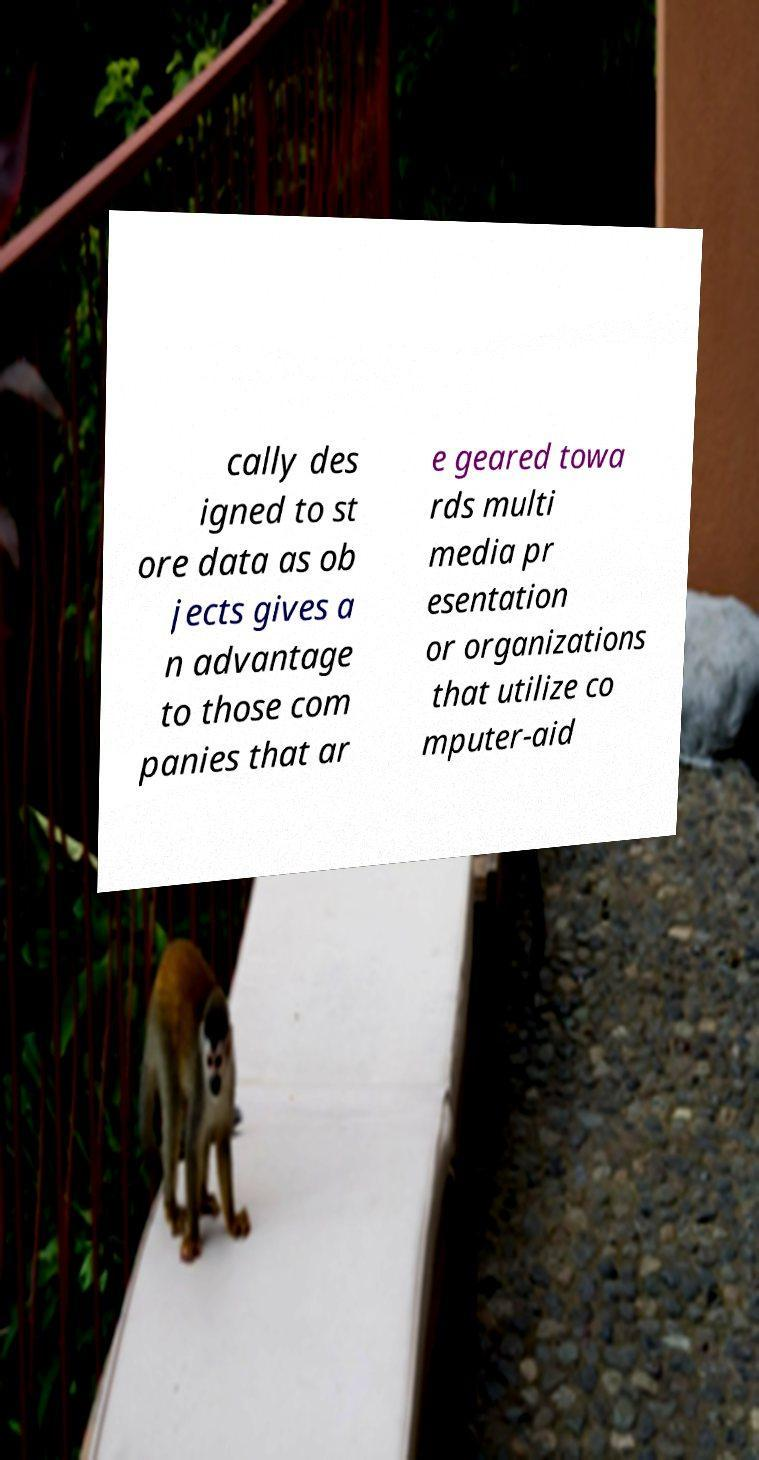Please read and relay the text visible in this image. What does it say? cally des igned to st ore data as ob jects gives a n advantage to those com panies that ar e geared towa rds multi media pr esentation or organizations that utilize co mputer-aid 